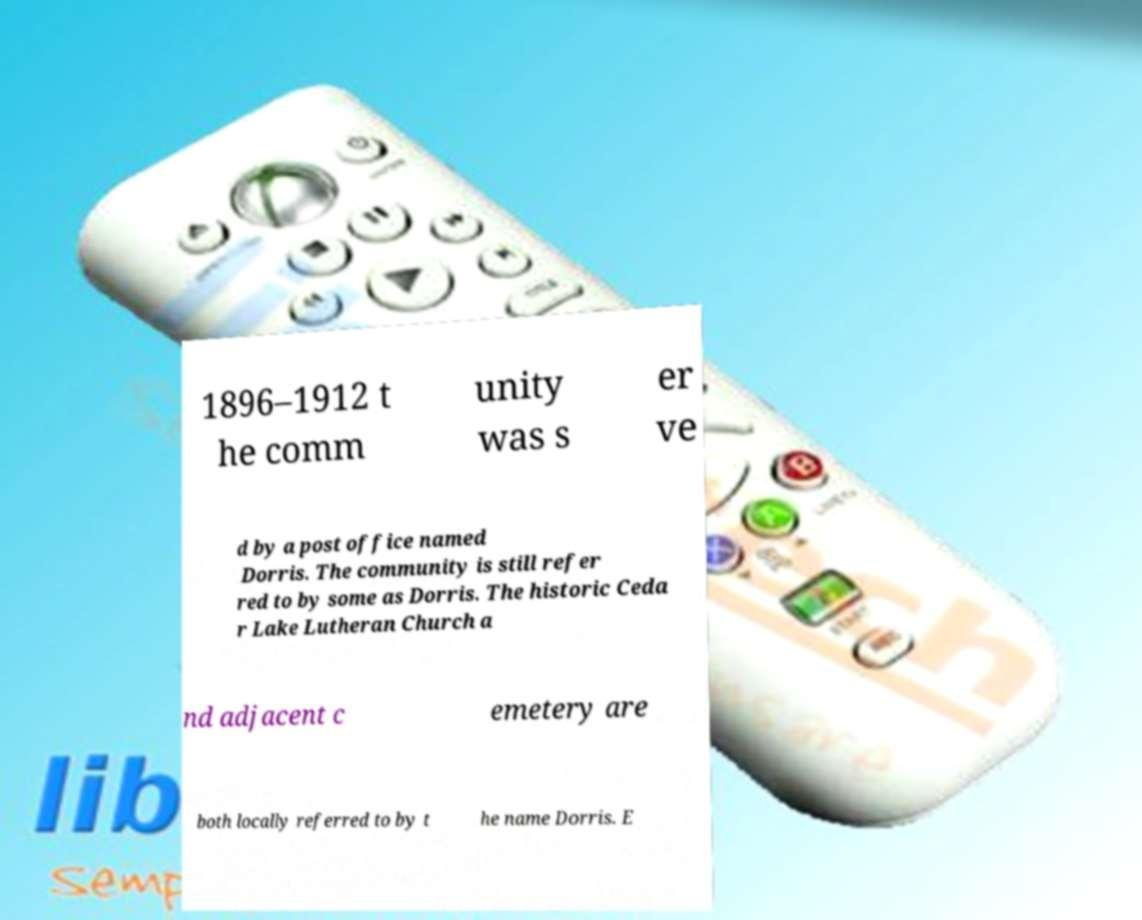Can you read and provide the text displayed in the image?This photo seems to have some interesting text. Can you extract and type it out for me? 1896–1912 t he comm unity was s er ve d by a post office named Dorris. The community is still refer red to by some as Dorris. The historic Ceda r Lake Lutheran Church a nd adjacent c emetery are both locally referred to by t he name Dorris. E 